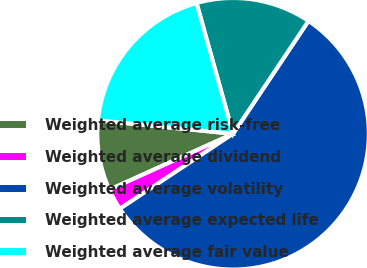Convert chart. <chart><loc_0><loc_0><loc_500><loc_500><pie_chart><fcel>Weighted average risk-free<fcel>Weighted average dividend<fcel>Weighted average volatility<fcel>Weighted average expected life<fcel>Weighted average fair value<nl><fcel>8.34%<fcel>2.55%<fcel>56.31%<fcel>13.71%<fcel>19.09%<nl></chart> 